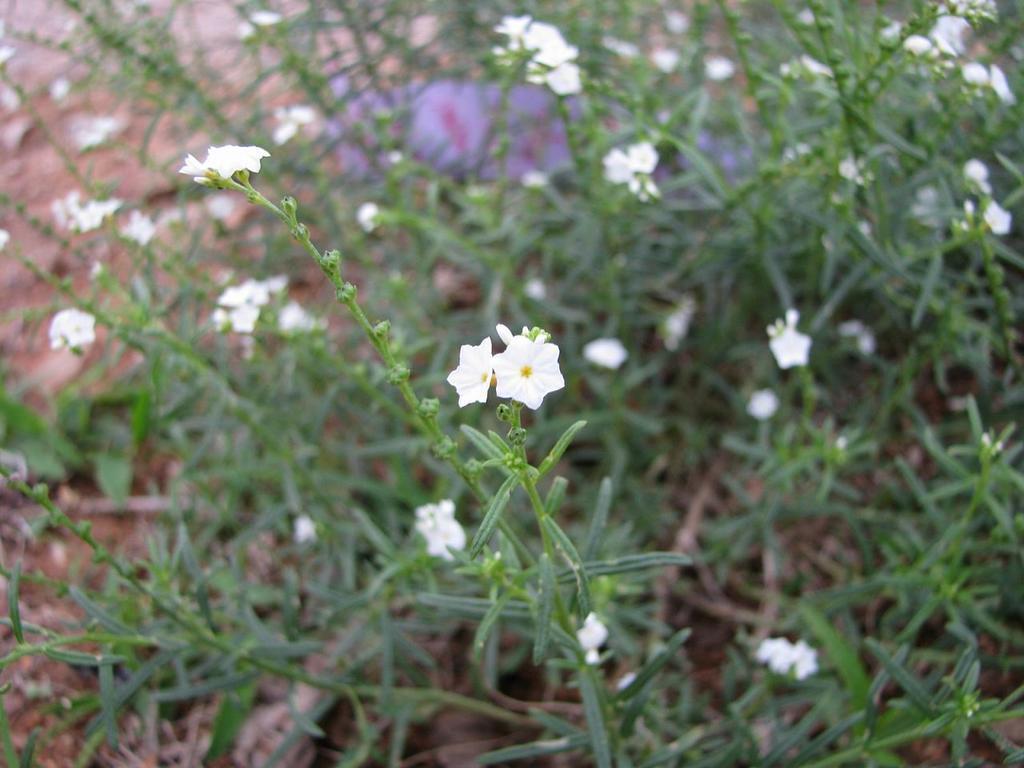Could you give a brief overview of what you see in this image? In this picture we can see white color small flowers seen in the middle of the image. Behind we can see green plants on the ground. 